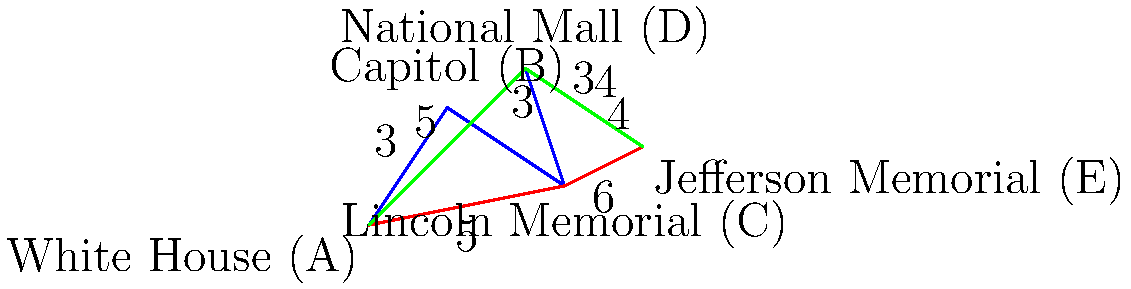In The Division 2, you need to navigate through Washington D.C. landmarks efficiently. Given the map above showing the distances (in km) between key locations, what is the shortest path from the White House (A) to the Jefferson Memorial (E), and what is its total distance? To find the shortest path, we need to consider all possible routes from A to E and calculate their total distances:

1. Path A-B-C-D-E:
   Distance = 3 + 4 + 3 + 4 = 14 km

2. Path A-C-E:
   Distance = 5 + 6 = 11 km

3. Path A-D-E:
   Distance = 5 + 3 = 8 km

Comparing these distances:
- Path 1 (A-B-C-D-E): 14 km
- Path 2 (A-C-E): 11 km
- Path 3 (A-D-E): 8 km

The shortest path is A-D-E, with a total distance of 8 km.

This route takes you from the White House (A) directly to the National Mall (D), and then to the Jefferson Memorial (E), avoiding unnecessary detours through other landmarks.
Answer: A-D-E, 8 km 